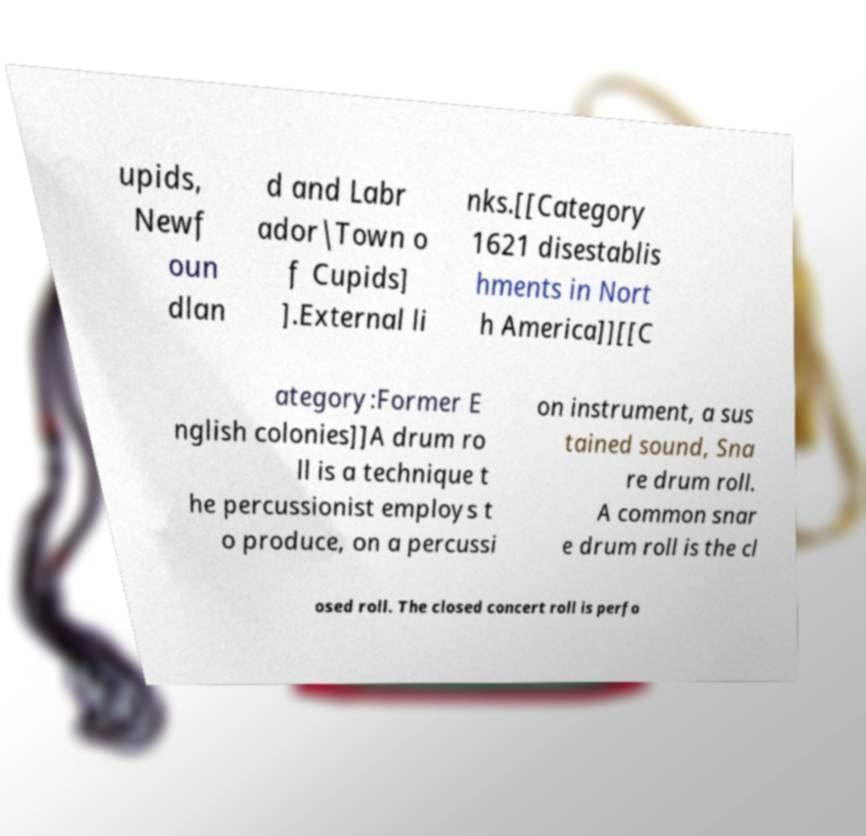Could you assist in decoding the text presented in this image and type it out clearly? upids, Newf oun dlan d and Labr ador|Town o f Cupids] ].External li nks.[[Category 1621 disestablis hments in Nort h America]][[C ategory:Former E nglish colonies]]A drum ro ll is a technique t he percussionist employs t o produce, on a percussi on instrument, a sus tained sound, Sna re drum roll. A common snar e drum roll is the cl osed roll. The closed concert roll is perfo 